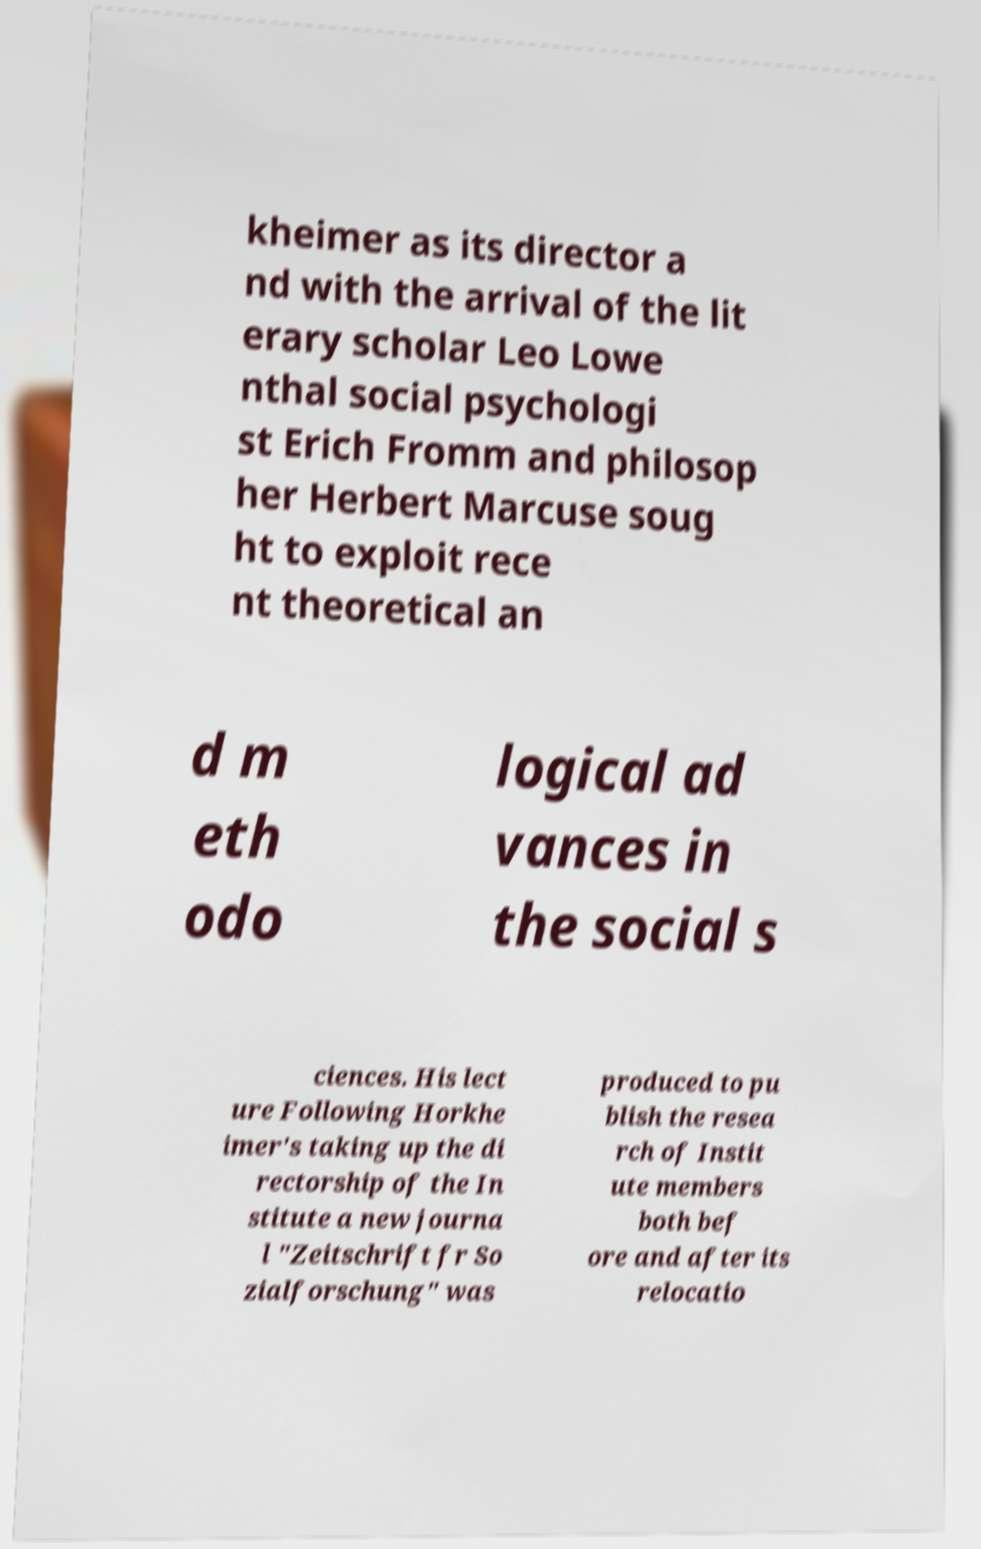Can you read and provide the text displayed in the image?This photo seems to have some interesting text. Can you extract and type it out for me? kheimer as its director a nd with the arrival of the lit erary scholar Leo Lowe nthal social psychologi st Erich Fromm and philosop her Herbert Marcuse soug ht to exploit rece nt theoretical an d m eth odo logical ad vances in the social s ciences. His lect ure Following Horkhe imer's taking up the di rectorship of the In stitute a new journa l "Zeitschrift fr So zialforschung" was produced to pu blish the resea rch of Instit ute members both bef ore and after its relocatio 